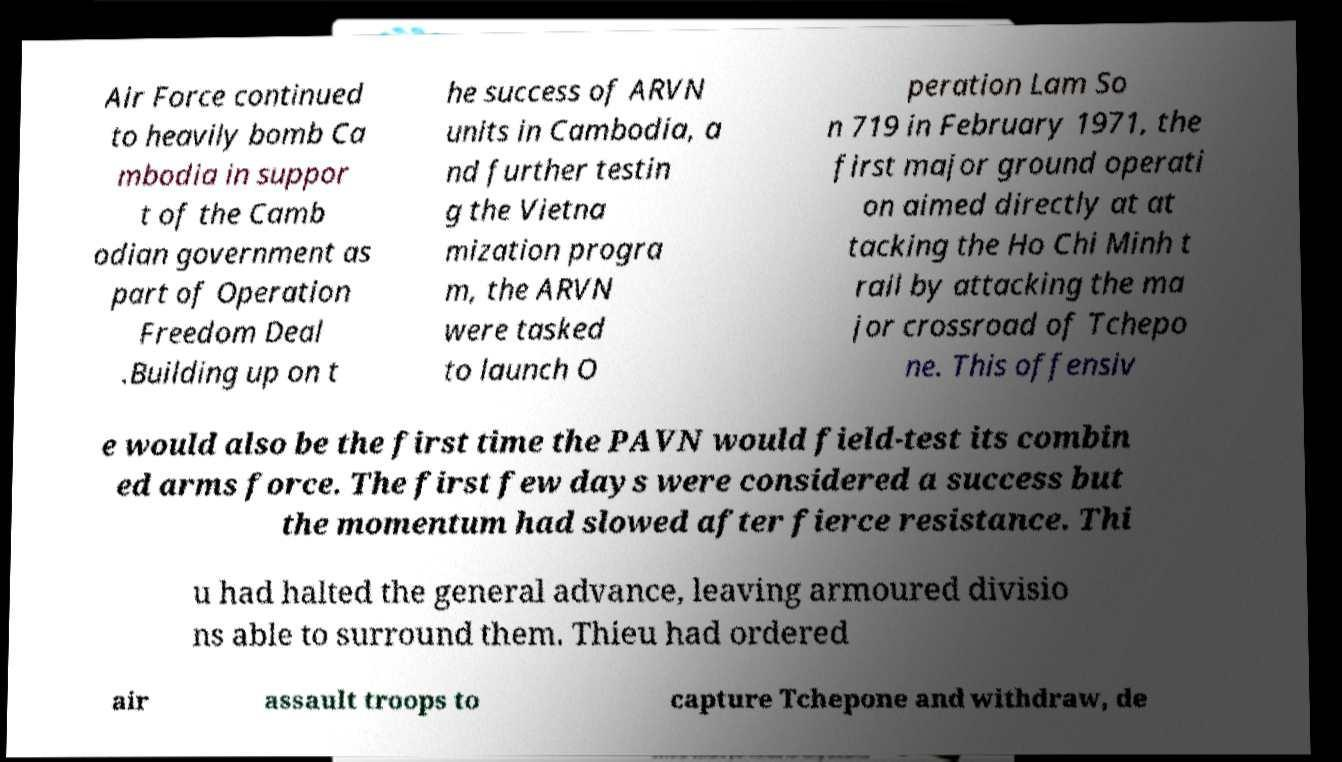There's text embedded in this image that I need extracted. Can you transcribe it verbatim? Air Force continued to heavily bomb Ca mbodia in suppor t of the Camb odian government as part of Operation Freedom Deal .Building up on t he success of ARVN units in Cambodia, a nd further testin g the Vietna mization progra m, the ARVN were tasked to launch O peration Lam So n 719 in February 1971, the first major ground operati on aimed directly at at tacking the Ho Chi Minh t rail by attacking the ma jor crossroad of Tchepo ne. This offensiv e would also be the first time the PAVN would field-test its combin ed arms force. The first few days were considered a success but the momentum had slowed after fierce resistance. Thi u had halted the general advance, leaving armoured divisio ns able to surround them. Thieu had ordered air assault troops to capture Tchepone and withdraw, de 